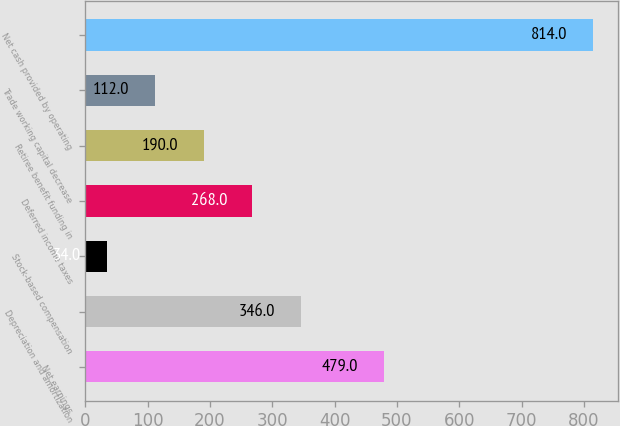<chart> <loc_0><loc_0><loc_500><loc_500><bar_chart><fcel>Net earnings<fcel>Depreciation and amortization<fcel>Stock-based compensation<fcel>Deferred income taxes<fcel>Retiree benefit funding in<fcel>Trade working capital decrease<fcel>Net cash provided by operating<nl><fcel>479<fcel>346<fcel>34<fcel>268<fcel>190<fcel>112<fcel>814<nl></chart> 